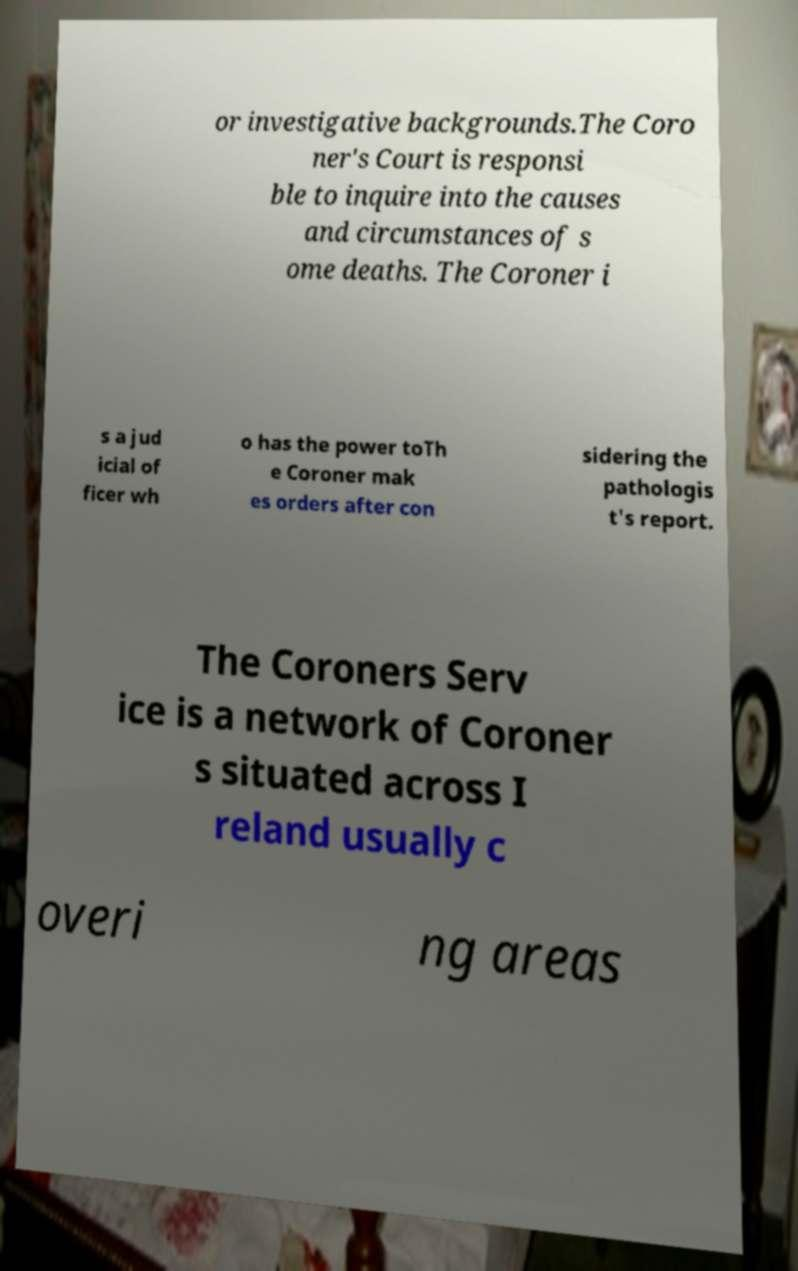For documentation purposes, I need the text within this image transcribed. Could you provide that? or investigative backgrounds.The Coro ner's Court is responsi ble to inquire into the causes and circumstances of s ome deaths. The Coroner i s a jud icial of ficer wh o has the power toTh e Coroner mak es orders after con sidering the pathologis t's report. The Coroners Serv ice is a network of Coroner s situated across I reland usually c overi ng areas 